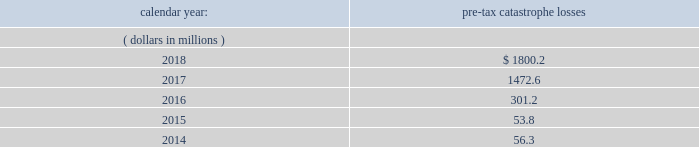Ireland .
Holdings ireland , everest dublin holdings , ireland re and ireland insurance conduct business in ireland and are subject to taxation in ireland .
Aavailable information .
The company 2019s annual reports on form 10-k , quarterly reports on form 10-q , current reports on form 8-k , proxy statements and amendments to those reports are available free of charge through the company 2019s internet website at http://www.everestre.com as soon as reasonably practicable after such reports are electronically filed with the securities and exchange commission ( the 201csec 201d ) .
Item 1a .
Risk factors in addition to the other information provided in this report , the following risk factors should be considered when evaluating an investment in our securities .
If the circumstances contemplated by the individual risk factors materialize , our business , financial condition and results of operations could be materially and adversely affected and the trading price of our common shares could decline significantly .
Risks relating to our business fluctuations in the financial markets could result in investment losses .
Prolonged and severe disruptions in the overall public and private debt and equity markets , such as occurred during 2008 , could result in significant realized and unrealized losses in our investment portfolio .
Although financial markets have significantly improved since 2008 , they could deteriorate in the future .
There could also be disruption in individual market sectors , such as occurred in the energy sector in recent years .
Such declines in the financial markets could result in significant realized and unrealized losses on investments and could have a material adverse impact on our results of operations , equity , business and insurer financial strength and debt ratings .
Our results could be adversely affected by catastrophic events .
We are exposed to unpredictable catastrophic events , including weather-related and other natural catastrophes , as well as acts of terrorism .
Any material reduction in our operating results caused by the occurrence of one or more catastrophes could inhibit our ability to pay dividends or to meet our interest and principal payment obligations .
By way of illustration , during the past five calendar years , pre-tax catastrophe losses , net of reinsurance , were as follows: .
Our losses from future catastrophic events could exceed our projections .
We use projections of possible losses from future catastrophic events of varying types and magnitudes as a strategic underwriting tool .
We use these loss projections to estimate our potential catastrophe losses in certain geographic areas and decide on the placement of retrocessional coverage or other actions to limit the extent of potential losses in a given geographic area .
These loss projections are approximations , reliant on a mix of quantitative and qualitative processes , and actual losses may exceed the projections by a material amount , resulting in a material adverse effect on our financial condition and results of operations. .
What are the total pre-tax catastrophe losses in the last three years? 
Computations: ((301.2 + 1472.6) / 1800.2)
Answer: 0.98533. 